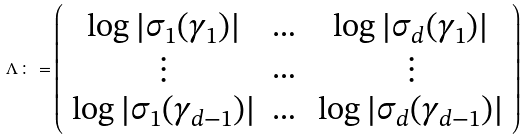Convert formula to latex. <formula><loc_0><loc_0><loc_500><loc_500>\Lambda \colon = \left ( \begin{array} { c c c } \log | \sigma _ { 1 } ( \gamma _ { 1 } ) | & \dots & \log | \sigma _ { d } ( \gamma _ { 1 } ) | \\ \vdots & \dots & \vdots \\ \log | \sigma _ { 1 } ( \gamma _ { d - 1 } ) | & \dots & \log | \sigma _ { d } ( \gamma _ { d - 1 } ) | \end{array} \right )</formula> 